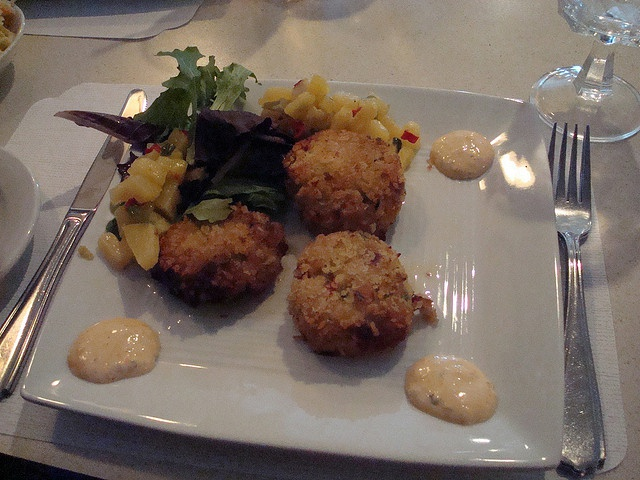Describe the objects in this image and their specific colors. I can see dining table in darkgray, gray, and black tones, sandwich in gray, black, maroon, and olive tones, sandwich in gray, maroon, brown, and black tones, sandwich in gray, maroon, brown, and black tones, and wine glass in gray and darkgray tones in this image. 